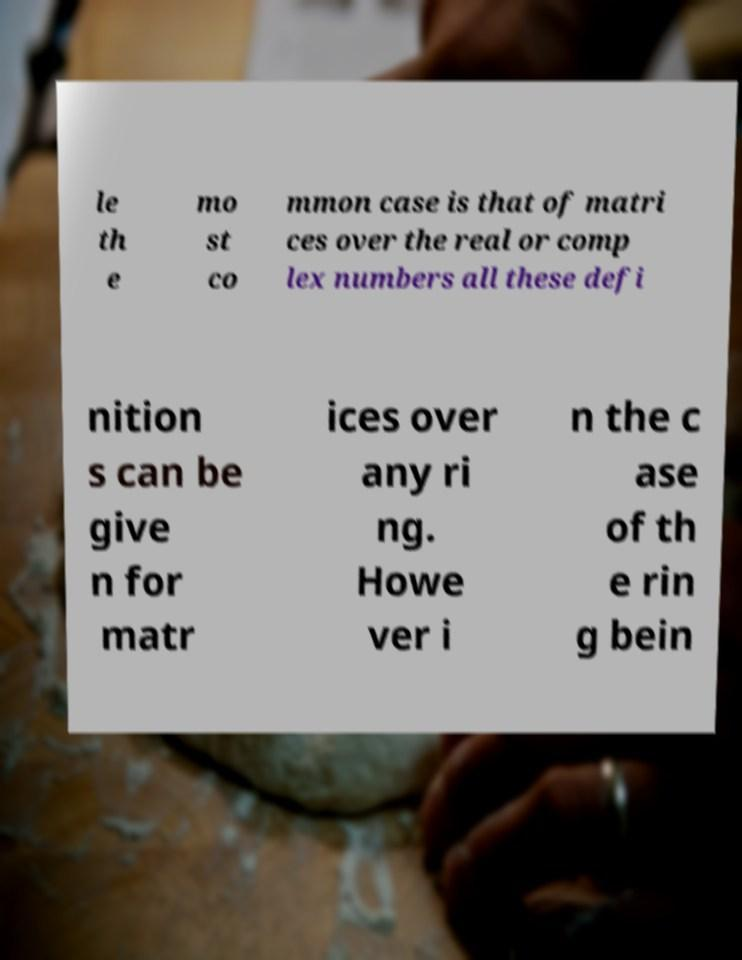There's text embedded in this image that I need extracted. Can you transcribe it verbatim? le th e mo st co mmon case is that of matri ces over the real or comp lex numbers all these defi nition s can be give n for matr ices over any ri ng. Howe ver i n the c ase of th e rin g bein 